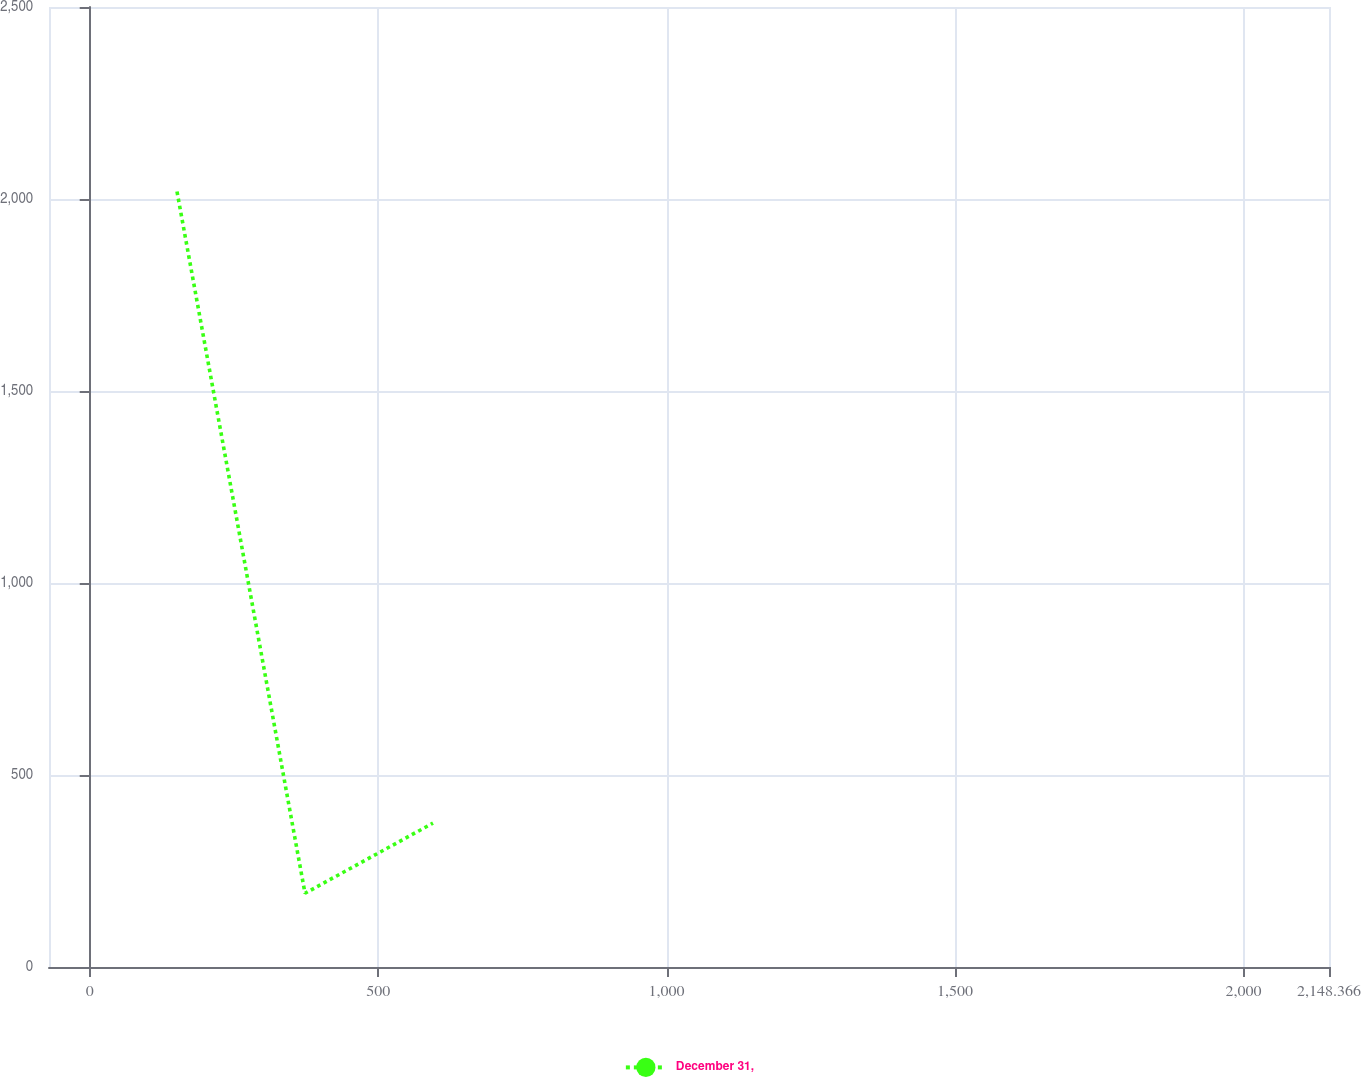<chart> <loc_0><loc_0><loc_500><loc_500><line_chart><ecel><fcel>December 31,<nl><fcel>151.32<fcel>2019.4<nl><fcel>373.21<fcel>192<nl><fcel>595.1<fcel>374.74<nl><fcel>2370.26<fcel>557.48<nl></chart> 